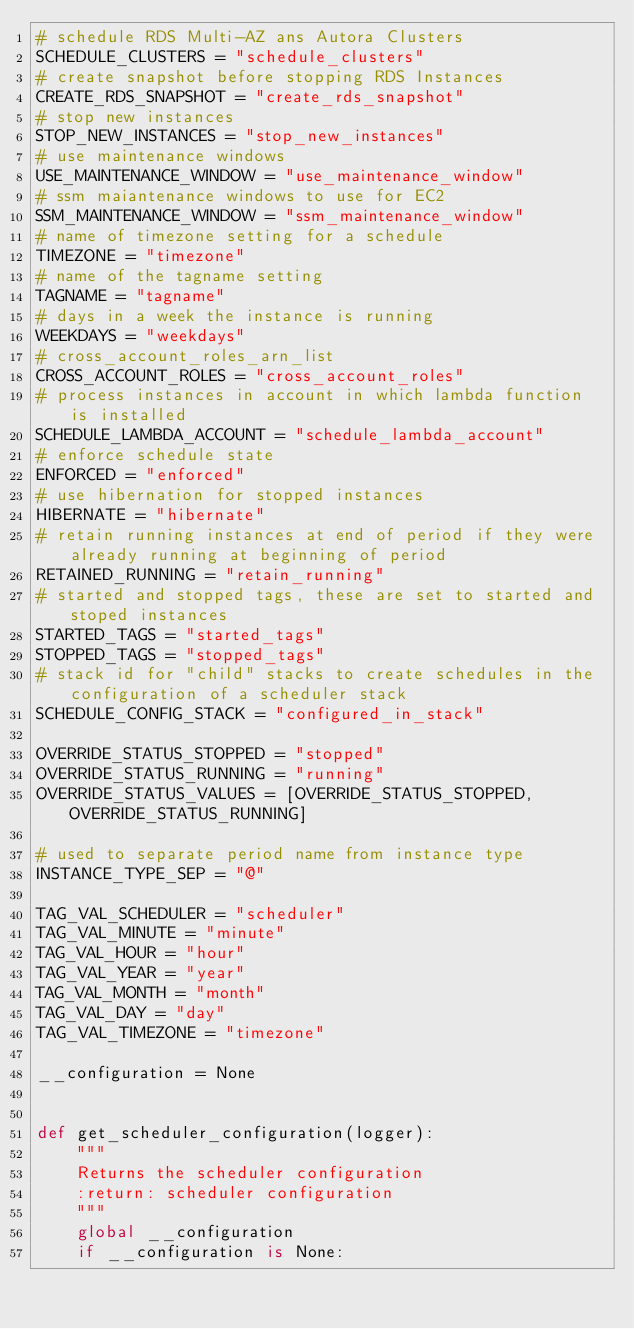<code> <loc_0><loc_0><loc_500><loc_500><_Python_># schedule RDS Multi-AZ ans Autora Clusters
SCHEDULE_CLUSTERS = "schedule_clusters"
# create snapshot before stopping RDS Instances
CREATE_RDS_SNAPSHOT = "create_rds_snapshot"
# stop new instances
STOP_NEW_INSTANCES = "stop_new_instances"
# use maintenance windows
USE_MAINTENANCE_WINDOW = "use_maintenance_window"
# ssm maiantenance windows to use for EC2
SSM_MAINTENANCE_WINDOW = "ssm_maintenance_window"
# name of timezone setting for a schedule
TIMEZONE = "timezone"
# name of the tagname setting
TAGNAME = "tagname"
# days in a week the instance is running
WEEKDAYS = "weekdays"
# cross_account_roles_arn_list
CROSS_ACCOUNT_ROLES = "cross_account_roles"
# process instances in account in which lambda function is installed
SCHEDULE_LAMBDA_ACCOUNT = "schedule_lambda_account"
# enforce schedule state
ENFORCED = "enforced"
# use hibernation for stopped instances
HIBERNATE = "hibernate"
# retain running instances at end of period if they were already running at beginning of period
RETAINED_RUNNING = "retain_running"
# started and stopped tags, these are set to started and stoped instances
STARTED_TAGS = "started_tags"
STOPPED_TAGS = "stopped_tags"
# stack id for "child" stacks to create schedules in the configuration of a scheduler stack
SCHEDULE_CONFIG_STACK = "configured_in_stack"

OVERRIDE_STATUS_STOPPED = "stopped"
OVERRIDE_STATUS_RUNNING = "running"
OVERRIDE_STATUS_VALUES = [OVERRIDE_STATUS_STOPPED, OVERRIDE_STATUS_RUNNING]

# used to separate period name from instance type
INSTANCE_TYPE_SEP = "@"

TAG_VAL_SCHEDULER = "scheduler"
TAG_VAL_MINUTE = "minute"
TAG_VAL_HOUR = "hour"
TAG_VAL_YEAR = "year"
TAG_VAL_MONTH = "month"
TAG_VAL_DAY = "day"
TAG_VAL_TIMEZONE = "timezone"

__configuration = None


def get_scheduler_configuration(logger):
    """
    Returns the scheduler configuration
    :return: scheduler configuration
    """
    global __configuration
    if __configuration is None:</code> 